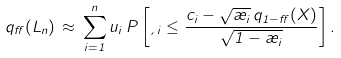Convert formula to latex. <formula><loc_0><loc_0><loc_500><loc_500>q _ { \alpha } ( L _ { n } ) \, \approx \, \sum _ { i = 1 } ^ { n } u _ { i } \, P \left [ \xi _ { i } \leq \frac { c _ { i } - \sqrt { \rho _ { i } } \, q _ { 1 - \alpha } ( X ) } { \sqrt { 1 - \rho _ { i } } } \right ] .</formula> 